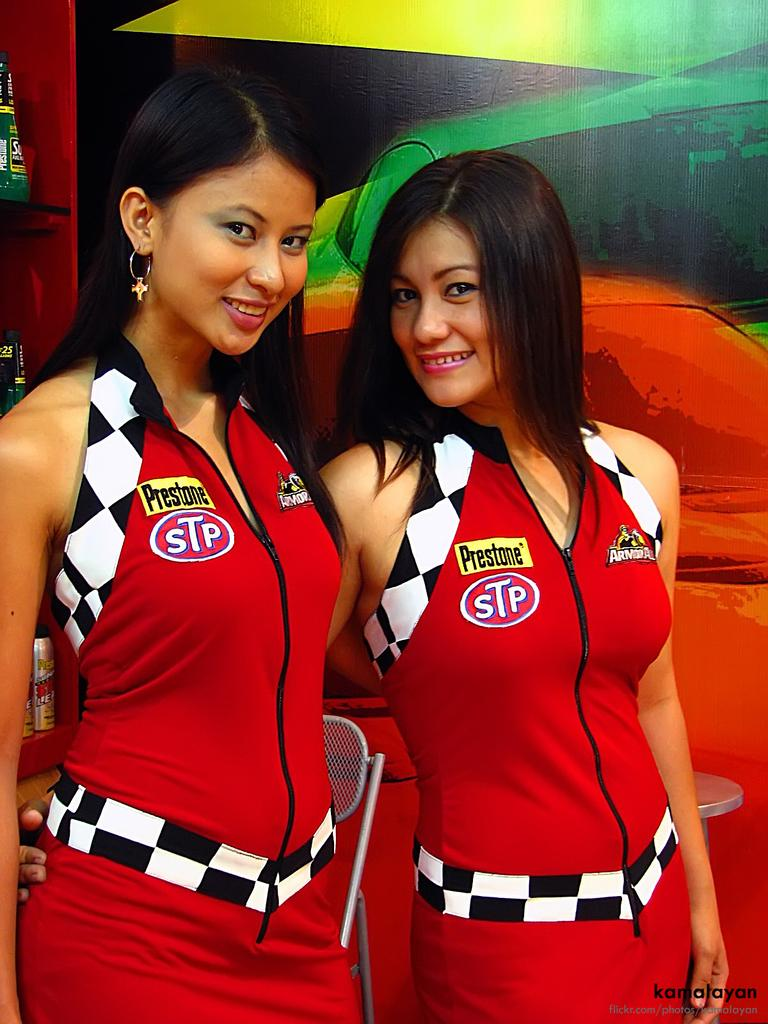<image>
Present a compact description of the photo's key features. Two women wearing red dresses with STP placed on their chests. 